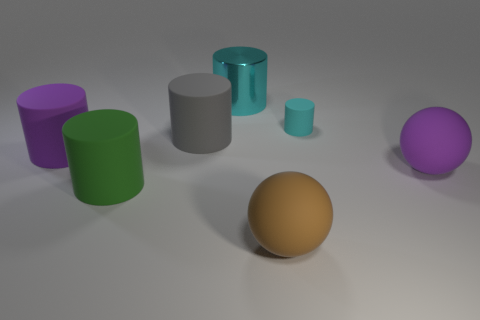What number of things are either matte balls behind the green rubber thing or things that are in front of the cyan shiny object?
Make the answer very short. 6. Does the purple matte sphere have the same size as the brown matte ball?
Offer a very short reply. Yes. Is there any other thing that has the same size as the purple matte cylinder?
Ensure brevity in your answer.  Yes. There is a cyan object that is on the left side of the brown thing; is its shape the same as the large purple thing on the left side of the gray matte object?
Offer a very short reply. Yes. What size is the brown rubber ball?
Make the answer very short. Large. There is a purple thing left of the large green cylinder in front of the big object behind the big gray rubber cylinder; what is it made of?
Your response must be concise. Rubber. What number of other things are there of the same color as the big metallic thing?
Give a very brief answer. 1. How many green things are balls or big cylinders?
Give a very brief answer. 1. What is the large cylinder that is behind the gray rubber cylinder made of?
Ensure brevity in your answer.  Metal. Is the material of the ball that is on the left side of the tiny cyan matte cylinder the same as the big green cylinder?
Give a very brief answer. Yes. 